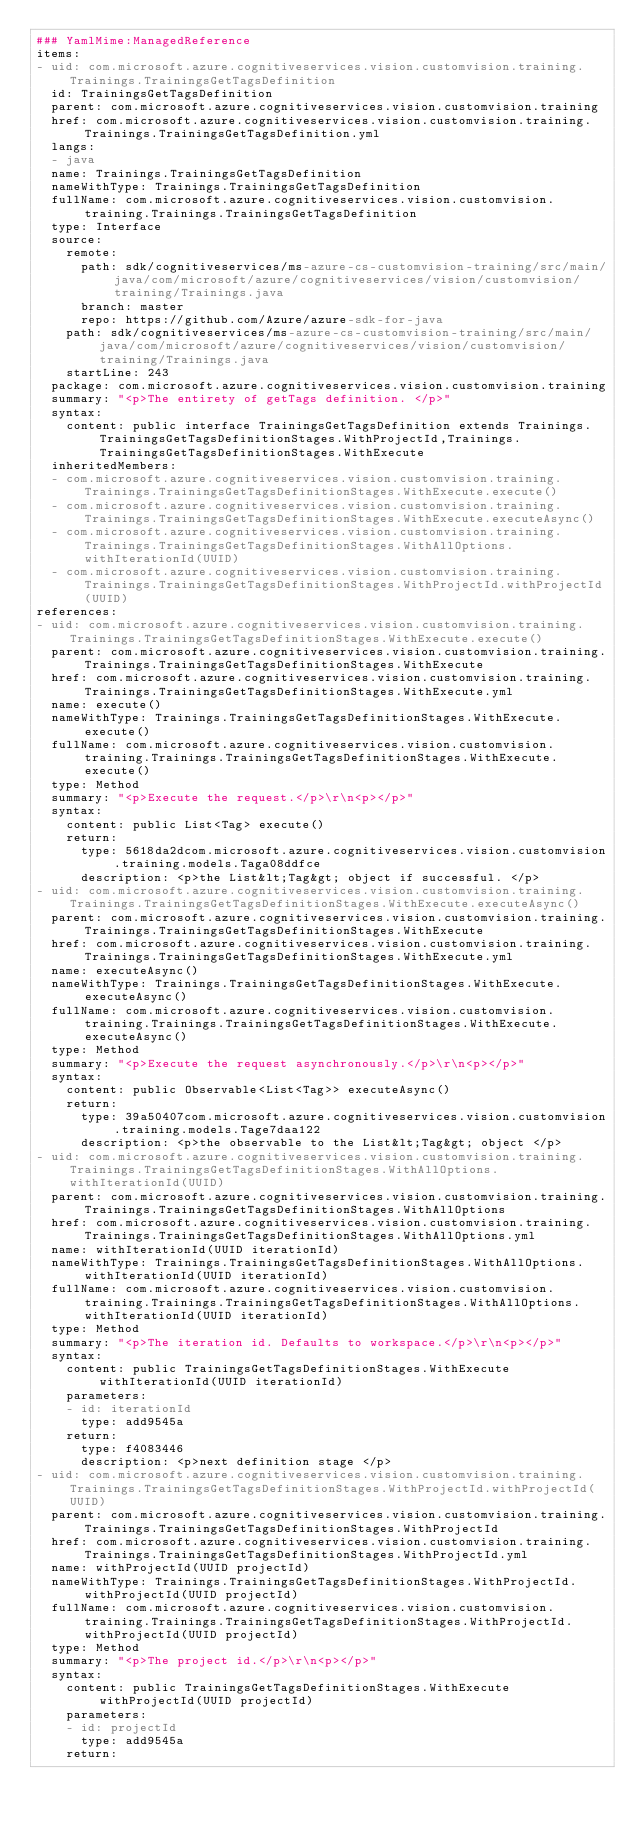Convert code to text. <code><loc_0><loc_0><loc_500><loc_500><_YAML_>### YamlMime:ManagedReference
items:
- uid: com.microsoft.azure.cognitiveservices.vision.customvision.training.Trainings.TrainingsGetTagsDefinition
  id: TrainingsGetTagsDefinition
  parent: com.microsoft.azure.cognitiveservices.vision.customvision.training
  href: com.microsoft.azure.cognitiveservices.vision.customvision.training.Trainings.TrainingsGetTagsDefinition.yml
  langs:
  - java
  name: Trainings.TrainingsGetTagsDefinition
  nameWithType: Trainings.TrainingsGetTagsDefinition
  fullName: com.microsoft.azure.cognitiveservices.vision.customvision.training.Trainings.TrainingsGetTagsDefinition
  type: Interface
  source:
    remote:
      path: sdk/cognitiveservices/ms-azure-cs-customvision-training/src/main/java/com/microsoft/azure/cognitiveservices/vision/customvision/training/Trainings.java
      branch: master
      repo: https://github.com/Azure/azure-sdk-for-java
    path: sdk/cognitiveservices/ms-azure-cs-customvision-training/src/main/java/com/microsoft/azure/cognitiveservices/vision/customvision/training/Trainings.java
    startLine: 243
  package: com.microsoft.azure.cognitiveservices.vision.customvision.training
  summary: "<p>The entirety of getTags definition. </p>"
  syntax:
    content: public interface TrainingsGetTagsDefinition extends Trainings.TrainingsGetTagsDefinitionStages.WithProjectId,Trainings.TrainingsGetTagsDefinitionStages.WithExecute
  inheritedMembers:
  - com.microsoft.azure.cognitiveservices.vision.customvision.training.Trainings.TrainingsGetTagsDefinitionStages.WithExecute.execute()
  - com.microsoft.azure.cognitiveservices.vision.customvision.training.Trainings.TrainingsGetTagsDefinitionStages.WithExecute.executeAsync()
  - com.microsoft.azure.cognitiveservices.vision.customvision.training.Trainings.TrainingsGetTagsDefinitionStages.WithAllOptions.withIterationId(UUID)
  - com.microsoft.azure.cognitiveservices.vision.customvision.training.Trainings.TrainingsGetTagsDefinitionStages.WithProjectId.withProjectId(UUID)
references:
- uid: com.microsoft.azure.cognitiveservices.vision.customvision.training.Trainings.TrainingsGetTagsDefinitionStages.WithExecute.execute()
  parent: com.microsoft.azure.cognitiveservices.vision.customvision.training.Trainings.TrainingsGetTagsDefinitionStages.WithExecute
  href: com.microsoft.azure.cognitiveservices.vision.customvision.training.Trainings.TrainingsGetTagsDefinitionStages.WithExecute.yml
  name: execute()
  nameWithType: Trainings.TrainingsGetTagsDefinitionStages.WithExecute.execute()
  fullName: com.microsoft.azure.cognitiveservices.vision.customvision.training.Trainings.TrainingsGetTagsDefinitionStages.WithExecute.execute()
  type: Method
  summary: "<p>Execute the request.</p>\r\n<p></p>"
  syntax:
    content: public List<Tag> execute()
    return:
      type: 5618da2dcom.microsoft.azure.cognitiveservices.vision.customvision.training.models.Taga08ddfce
      description: <p>the List&lt;Tag&gt; object if successful. </p>
- uid: com.microsoft.azure.cognitiveservices.vision.customvision.training.Trainings.TrainingsGetTagsDefinitionStages.WithExecute.executeAsync()
  parent: com.microsoft.azure.cognitiveservices.vision.customvision.training.Trainings.TrainingsGetTagsDefinitionStages.WithExecute
  href: com.microsoft.azure.cognitiveservices.vision.customvision.training.Trainings.TrainingsGetTagsDefinitionStages.WithExecute.yml
  name: executeAsync()
  nameWithType: Trainings.TrainingsGetTagsDefinitionStages.WithExecute.executeAsync()
  fullName: com.microsoft.azure.cognitiveservices.vision.customvision.training.Trainings.TrainingsGetTagsDefinitionStages.WithExecute.executeAsync()
  type: Method
  summary: "<p>Execute the request asynchronously.</p>\r\n<p></p>"
  syntax:
    content: public Observable<List<Tag>> executeAsync()
    return:
      type: 39a50407com.microsoft.azure.cognitiveservices.vision.customvision.training.models.Tage7daa122
      description: <p>the observable to the List&lt;Tag&gt; object </p>
- uid: com.microsoft.azure.cognitiveservices.vision.customvision.training.Trainings.TrainingsGetTagsDefinitionStages.WithAllOptions.withIterationId(UUID)
  parent: com.microsoft.azure.cognitiveservices.vision.customvision.training.Trainings.TrainingsGetTagsDefinitionStages.WithAllOptions
  href: com.microsoft.azure.cognitiveservices.vision.customvision.training.Trainings.TrainingsGetTagsDefinitionStages.WithAllOptions.yml
  name: withIterationId(UUID iterationId)
  nameWithType: Trainings.TrainingsGetTagsDefinitionStages.WithAllOptions.withIterationId(UUID iterationId)
  fullName: com.microsoft.azure.cognitiveservices.vision.customvision.training.Trainings.TrainingsGetTagsDefinitionStages.WithAllOptions.withIterationId(UUID iterationId)
  type: Method
  summary: "<p>The iteration id. Defaults to workspace.</p>\r\n<p></p>"
  syntax:
    content: public TrainingsGetTagsDefinitionStages.WithExecute withIterationId(UUID iterationId)
    parameters:
    - id: iterationId
      type: add9545a
    return:
      type: f4083446
      description: <p>next definition stage </p>
- uid: com.microsoft.azure.cognitiveservices.vision.customvision.training.Trainings.TrainingsGetTagsDefinitionStages.WithProjectId.withProjectId(UUID)
  parent: com.microsoft.azure.cognitiveservices.vision.customvision.training.Trainings.TrainingsGetTagsDefinitionStages.WithProjectId
  href: com.microsoft.azure.cognitiveservices.vision.customvision.training.Trainings.TrainingsGetTagsDefinitionStages.WithProjectId.yml
  name: withProjectId(UUID projectId)
  nameWithType: Trainings.TrainingsGetTagsDefinitionStages.WithProjectId.withProjectId(UUID projectId)
  fullName: com.microsoft.azure.cognitiveservices.vision.customvision.training.Trainings.TrainingsGetTagsDefinitionStages.WithProjectId.withProjectId(UUID projectId)
  type: Method
  summary: "<p>The project id.</p>\r\n<p></p>"
  syntax:
    content: public TrainingsGetTagsDefinitionStages.WithExecute withProjectId(UUID projectId)
    parameters:
    - id: projectId
      type: add9545a
    return:</code> 